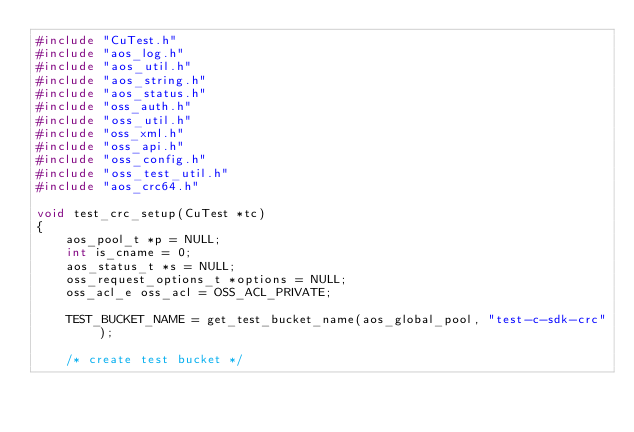<code> <loc_0><loc_0><loc_500><loc_500><_C_>#include "CuTest.h"
#include "aos_log.h"
#include "aos_util.h"
#include "aos_string.h"
#include "aos_status.h"
#include "oss_auth.h"
#include "oss_util.h"
#include "oss_xml.h"
#include "oss_api.h"
#include "oss_config.h"
#include "oss_test_util.h"
#include "aos_crc64.h"

void test_crc_setup(CuTest *tc)
{
    aos_pool_t *p = NULL;
    int is_cname = 0;
    aos_status_t *s = NULL;
    oss_request_options_t *options = NULL;
    oss_acl_e oss_acl = OSS_ACL_PRIVATE;

    TEST_BUCKET_NAME = get_test_bucket_name(aos_global_pool, "test-c-sdk-crc");

    /* create test bucket */</code> 